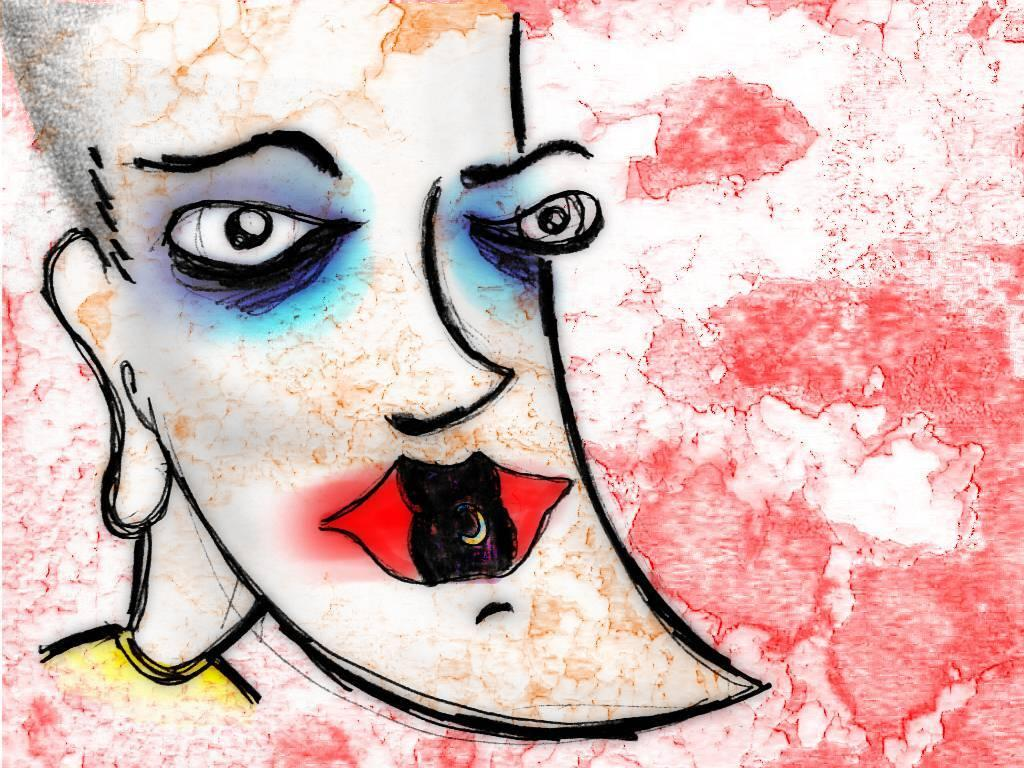What type of object is featured in the image? The image contains an artwork. What colors are used in the artwork? The artwork uses black, red, and white colors. Is there an umbrella featured in the artwork? There is no mention of an umbrella in the provided facts, so we cannot determine if it is present in the artwork. What type of reward is depicted in the artwork? There is no mention of a reward in the provided facts, so we cannot determine if it is present in the artwork. 